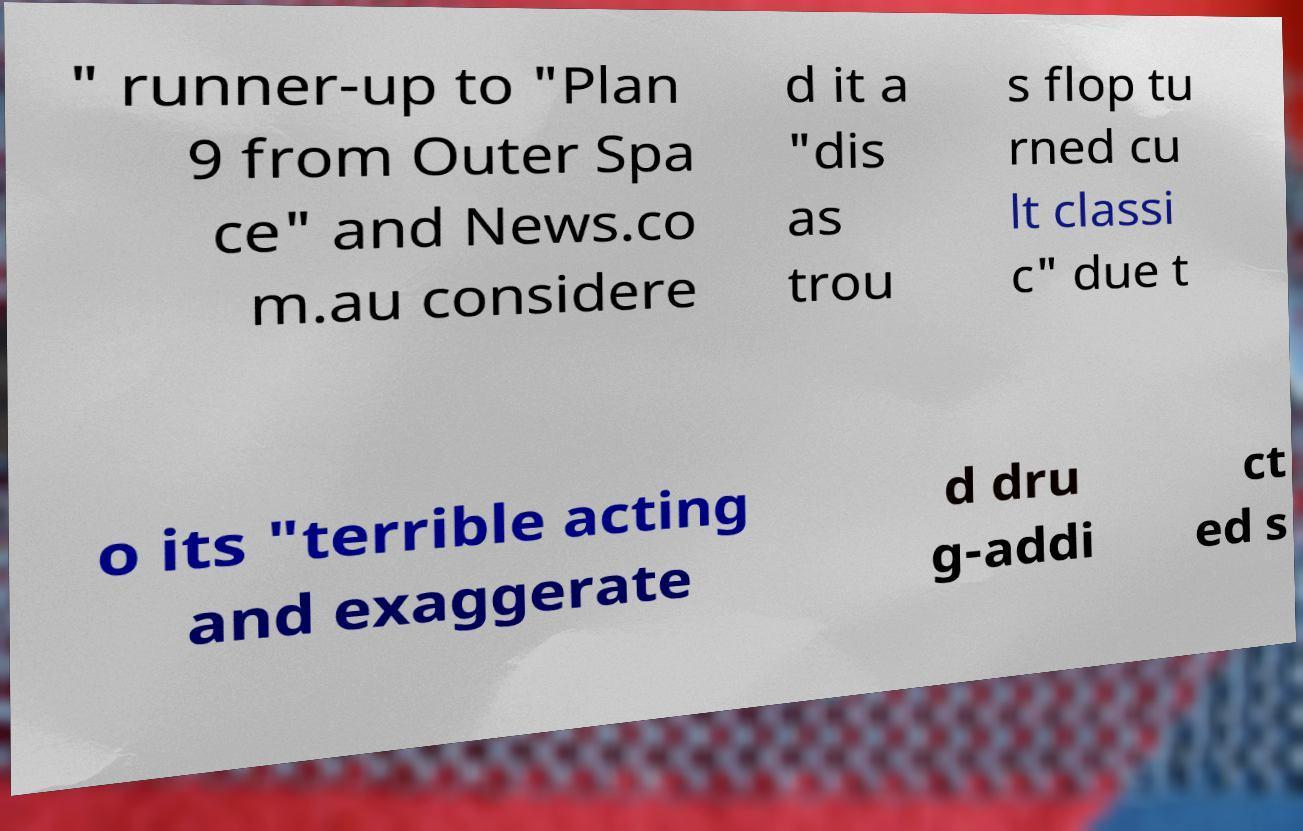Can you read and provide the text displayed in the image?This photo seems to have some interesting text. Can you extract and type it out for me? " runner-up to "Plan 9 from Outer Spa ce" and News.co m.au considere d it a "dis as trou s flop tu rned cu lt classi c" due t o its "terrible acting and exaggerate d dru g-addi ct ed s 